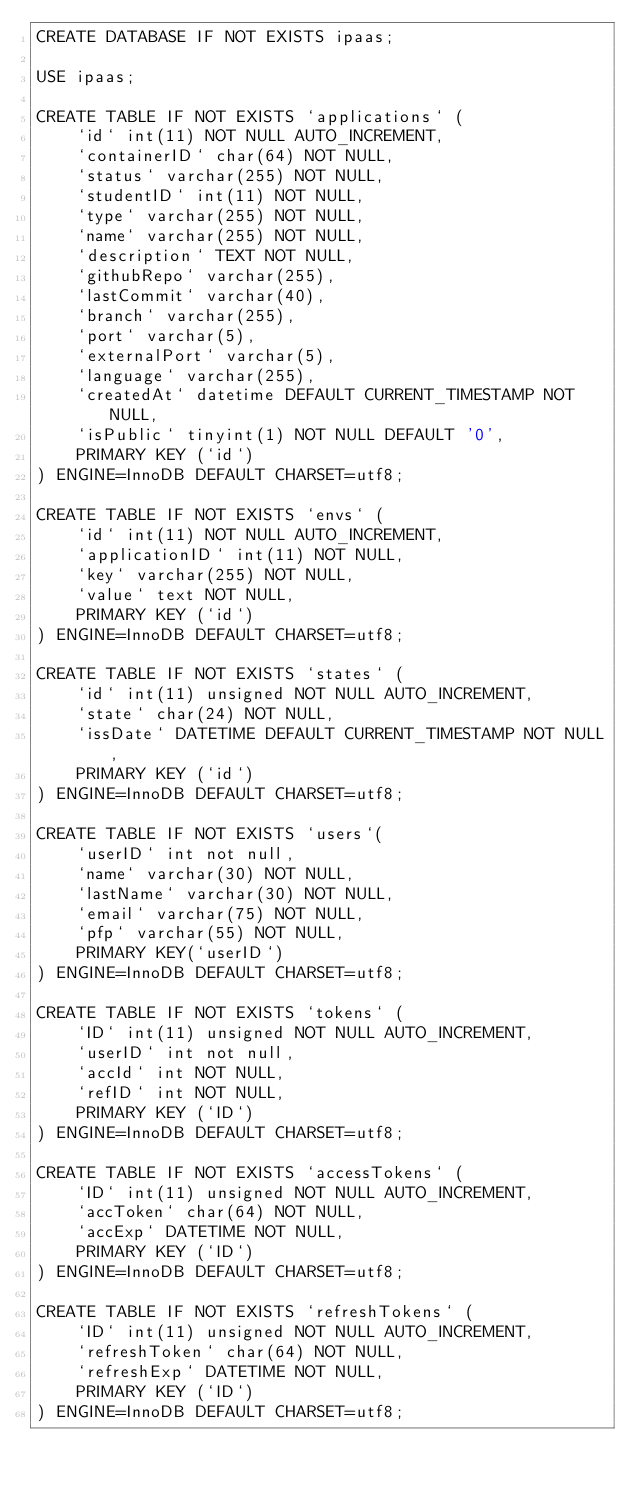<code> <loc_0><loc_0><loc_500><loc_500><_SQL_>CREATE DATABASE IF NOT EXISTS ipaas;

USE ipaas;

CREATE TABLE IF NOT EXISTS `applications` (
    `id` int(11) NOT NULL AUTO_INCREMENT,
    `containerID` char(64) NOT NULL,
    `status` varchar(255) NOT NULL,
    `studentID` int(11) NOT NULL,
    `type` varchar(255) NOT NULL,
    `name` varchar(255) NOT NULL,
    `description` TEXT NOT NULL,
    `githubRepo` varchar(255),
    `lastCommit` varchar(40),
    `branch` varchar(255),
    `port` varchar(5),
    `externalPort` varchar(5),
    `language` varchar(255),
    `createdAt` datetime DEFAULT CURRENT_TIMESTAMP NOT NULL,
    `isPublic` tinyint(1) NOT NULL DEFAULT '0',
    PRIMARY KEY (`id`)
) ENGINE=InnoDB DEFAULT CHARSET=utf8;

CREATE TABLE IF NOT EXISTS `envs` (
    `id` int(11) NOT NULL AUTO_INCREMENT,
    `applicationID` int(11) NOT NULL,
    `key` varchar(255) NOT NULL,
    `value` text NOT NULL,
    PRIMARY KEY (`id`)
) ENGINE=InnoDB DEFAULT CHARSET=utf8;

CREATE TABLE IF NOT EXISTS `states` (
    `id` int(11) unsigned NOT NULL AUTO_INCREMENT,
    `state` char(24) NOT NULL,
    `issDate` DATETIME DEFAULT CURRENT_TIMESTAMP NOT NULL,
    PRIMARY KEY (`id`)
) ENGINE=InnoDB DEFAULT CHARSET=utf8;

CREATE TABLE IF NOT EXISTS `users`(
    `userID` int not null,
    `name` varchar(30) NOT NULL,
    `lastName` varchar(30) NOT NULL,
    `email` varchar(75) NOT NULL,
    `pfp` varchar(55) NOT NULL,
    PRIMARY KEY(`userID`)
) ENGINE=InnoDB DEFAULT CHARSET=utf8;

CREATE TABLE IF NOT EXISTS `tokens` (
    `ID` int(11) unsigned NOT NULL AUTO_INCREMENT,
    `userID` int not null,
    `accId` int NOT NULL,
    `refID` int NOT NULL,
    PRIMARY KEY (`ID`)
) ENGINE=InnoDB DEFAULT CHARSET=utf8;

CREATE TABLE IF NOT EXISTS `accessTokens` (
    `ID` int(11) unsigned NOT NULL AUTO_INCREMENT,
    `accToken` char(64) NOT NULL,
    `accExp` DATETIME NOT NULL,
    PRIMARY KEY (`ID`)
) ENGINE=InnoDB DEFAULT CHARSET=utf8;

CREATE TABLE IF NOT EXISTS `refreshTokens` (
    `ID` int(11) unsigned NOT NULL AUTO_INCREMENT,
    `refreshToken` char(64) NOT NULL,
    `refreshExp` DATETIME NOT NULL,
    PRIMARY KEY (`ID`)
) ENGINE=InnoDB DEFAULT CHARSET=utf8;

</code> 